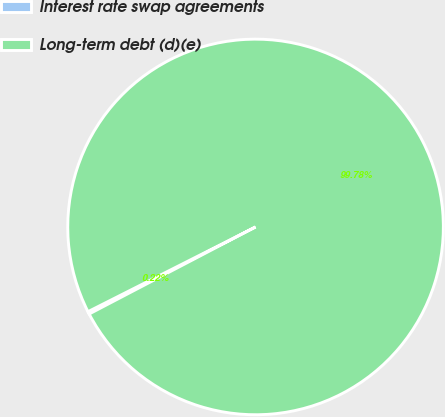Convert chart. <chart><loc_0><loc_0><loc_500><loc_500><pie_chart><fcel>Interest rate swap agreements<fcel>Long-term debt (d)(e)<nl><fcel>0.22%<fcel>99.78%<nl></chart> 